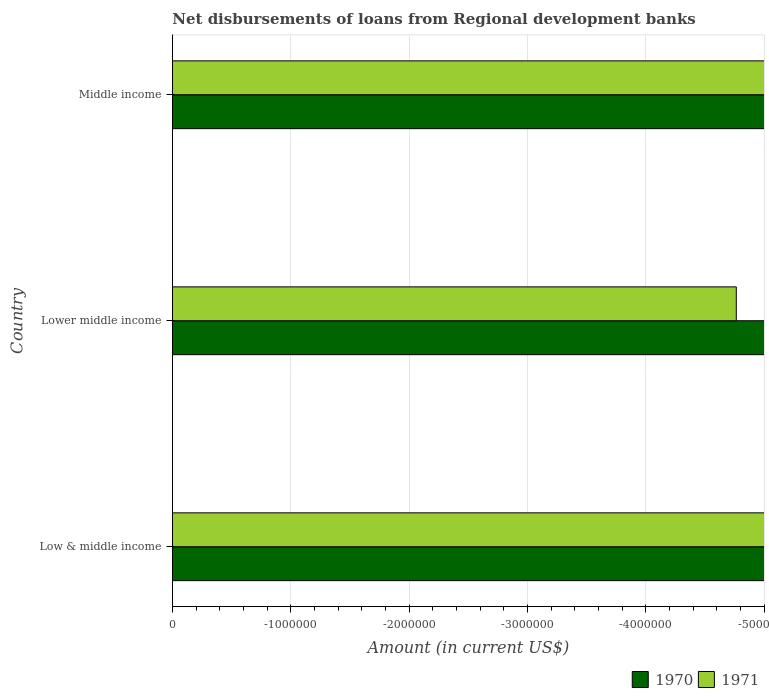Are the number of bars per tick equal to the number of legend labels?
Offer a very short reply. No. Are the number of bars on each tick of the Y-axis equal?
Provide a short and direct response. Yes. How many bars are there on the 1st tick from the bottom?
Keep it short and to the point. 0. What is the amount of disbursements of loans from regional development banks in 1971 in Low & middle income?
Make the answer very short. 0. Across all countries, what is the minimum amount of disbursements of loans from regional development banks in 1970?
Your answer should be very brief. 0. What is the total amount of disbursements of loans from regional development banks in 1970 in the graph?
Keep it short and to the point. 0. In how many countries, is the amount of disbursements of loans from regional development banks in 1971 greater than the average amount of disbursements of loans from regional development banks in 1971 taken over all countries?
Your answer should be compact. 0. Are all the bars in the graph horizontal?
Ensure brevity in your answer.  Yes. Are the values on the major ticks of X-axis written in scientific E-notation?
Ensure brevity in your answer.  No. Where does the legend appear in the graph?
Keep it short and to the point. Bottom right. How many legend labels are there?
Your answer should be compact. 2. How are the legend labels stacked?
Your answer should be compact. Horizontal. What is the title of the graph?
Your answer should be compact. Net disbursements of loans from Regional development banks. What is the label or title of the X-axis?
Provide a short and direct response. Amount (in current US$). What is the label or title of the Y-axis?
Your answer should be compact. Country. What is the Amount (in current US$) in 1971 in Low & middle income?
Keep it short and to the point. 0. What is the Amount (in current US$) in 1971 in Middle income?
Provide a succinct answer. 0. What is the total Amount (in current US$) in 1970 in the graph?
Your response must be concise. 0. What is the average Amount (in current US$) of 1970 per country?
Provide a short and direct response. 0. What is the average Amount (in current US$) of 1971 per country?
Provide a succinct answer. 0. 